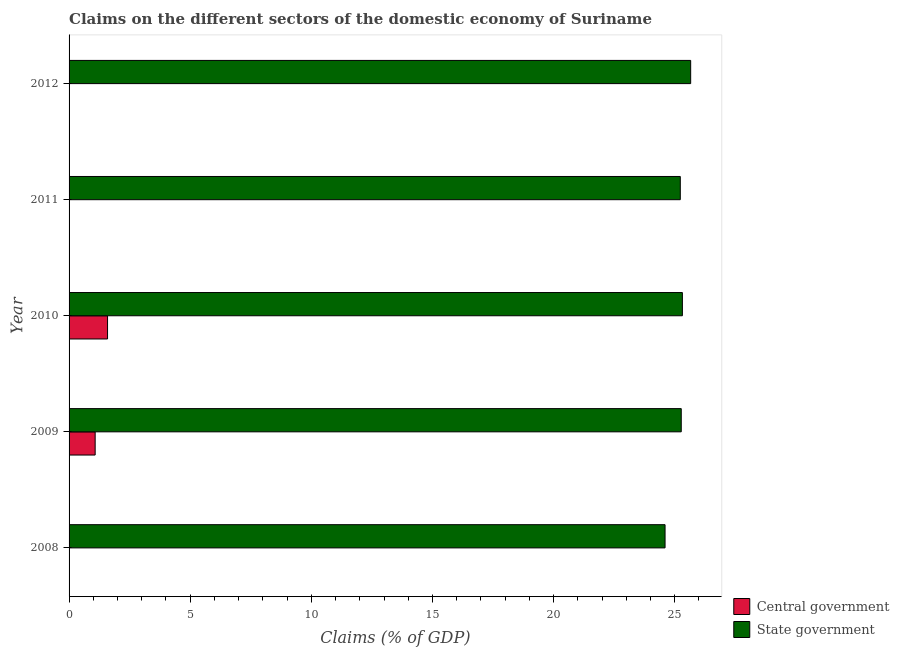What is the claims on state government in 2009?
Offer a very short reply. 25.27. Across all years, what is the maximum claims on state government?
Provide a short and direct response. 25.66. Across all years, what is the minimum claims on central government?
Make the answer very short. 0. What is the total claims on central government in the graph?
Provide a succinct answer. 2.67. What is the difference between the claims on state government in 2009 and that in 2010?
Offer a terse response. -0.05. What is the difference between the claims on central government in 2012 and the claims on state government in 2008?
Provide a short and direct response. -24.6. What is the average claims on central government per year?
Give a very brief answer. 0.53. In the year 2010, what is the difference between the claims on state government and claims on central government?
Your answer should be very brief. 23.73. In how many years, is the claims on central government greater than 1 %?
Provide a succinct answer. 2. Is the difference between the claims on state government in 2009 and 2010 greater than the difference between the claims on central government in 2009 and 2010?
Offer a terse response. Yes. What is the difference between the highest and the lowest claims on central government?
Provide a succinct answer. 1.59. In how many years, is the claims on central government greater than the average claims on central government taken over all years?
Offer a very short reply. 2. Is the sum of the claims on state government in 2008 and 2011 greater than the maximum claims on central government across all years?
Your response must be concise. Yes. How many bars are there?
Provide a succinct answer. 7. What is the difference between two consecutive major ticks on the X-axis?
Your response must be concise. 5. Where does the legend appear in the graph?
Keep it short and to the point. Bottom right. What is the title of the graph?
Provide a succinct answer. Claims on the different sectors of the domestic economy of Suriname. What is the label or title of the X-axis?
Your answer should be compact. Claims (% of GDP). What is the Claims (% of GDP) in State government in 2008?
Provide a short and direct response. 24.6. What is the Claims (% of GDP) of Central government in 2009?
Your response must be concise. 1.08. What is the Claims (% of GDP) in State government in 2009?
Your answer should be compact. 25.27. What is the Claims (% of GDP) of Central government in 2010?
Your answer should be very brief. 1.59. What is the Claims (% of GDP) of State government in 2010?
Offer a terse response. 25.32. What is the Claims (% of GDP) of Central government in 2011?
Make the answer very short. 0. What is the Claims (% of GDP) in State government in 2011?
Provide a short and direct response. 25.23. What is the Claims (% of GDP) of Central government in 2012?
Give a very brief answer. 0. What is the Claims (% of GDP) of State government in 2012?
Offer a very short reply. 25.66. Across all years, what is the maximum Claims (% of GDP) of Central government?
Provide a short and direct response. 1.59. Across all years, what is the maximum Claims (% of GDP) in State government?
Give a very brief answer. 25.66. Across all years, what is the minimum Claims (% of GDP) of State government?
Offer a very short reply. 24.6. What is the total Claims (% of GDP) of Central government in the graph?
Provide a short and direct response. 2.67. What is the total Claims (% of GDP) in State government in the graph?
Your answer should be compact. 126.08. What is the difference between the Claims (% of GDP) of State government in 2008 and that in 2009?
Your response must be concise. -0.67. What is the difference between the Claims (% of GDP) of State government in 2008 and that in 2010?
Provide a succinct answer. -0.72. What is the difference between the Claims (% of GDP) in State government in 2008 and that in 2011?
Offer a terse response. -0.63. What is the difference between the Claims (% of GDP) of State government in 2008 and that in 2012?
Offer a terse response. -1.06. What is the difference between the Claims (% of GDP) in Central government in 2009 and that in 2010?
Make the answer very short. -0.51. What is the difference between the Claims (% of GDP) of State government in 2009 and that in 2010?
Provide a succinct answer. -0.05. What is the difference between the Claims (% of GDP) in State government in 2009 and that in 2011?
Provide a succinct answer. 0.04. What is the difference between the Claims (% of GDP) in State government in 2009 and that in 2012?
Your answer should be compact. -0.39. What is the difference between the Claims (% of GDP) of State government in 2010 and that in 2011?
Your answer should be compact. 0.09. What is the difference between the Claims (% of GDP) of State government in 2010 and that in 2012?
Provide a short and direct response. -0.34. What is the difference between the Claims (% of GDP) of State government in 2011 and that in 2012?
Your answer should be compact. -0.43. What is the difference between the Claims (% of GDP) in Central government in 2009 and the Claims (% of GDP) in State government in 2010?
Your response must be concise. -24.24. What is the difference between the Claims (% of GDP) in Central government in 2009 and the Claims (% of GDP) in State government in 2011?
Ensure brevity in your answer.  -24.15. What is the difference between the Claims (% of GDP) of Central government in 2009 and the Claims (% of GDP) of State government in 2012?
Provide a short and direct response. -24.58. What is the difference between the Claims (% of GDP) of Central government in 2010 and the Claims (% of GDP) of State government in 2011?
Make the answer very short. -23.64. What is the difference between the Claims (% of GDP) in Central government in 2010 and the Claims (% of GDP) in State government in 2012?
Keep it short and to the point. -24.07. What is the average Claims (% of GDP) in Central government per year?
Your response must be concise. 0.53. What is the average Claims (% of GDP) in State government per year?
Keep it short and to the point. 25.22. In the year 2009, what is the difference between the Claims (% of GDP) of Central government and Claims (% of GDP) of State government?
Provide a succinct answer. -24.19. In the year 2010, what is the difference between the Claims (% of GDP) in Central government and Claims (% of GDP) in State government?
Offer a very short reply. -23.73. What is the ratio of the Claims (% of GDP) of State government in 2008 to that in 2009?
Offer a very short reply. 0.97. What is the ratio of the Claims (% of GDP) of State government in 2008 to that in 2010?
Keep it short and to the point. 0.97. What is the ratio of the Claims (% of GDP) of State government in 2008 to that in 2011?
Your response must be concise. 0.98. What is the ratio of the Claims (% of GDP) of State government in 2008 to that in 2012?
Offer a terse response. 0.96. What is the ratio of the Claims (% of GDP) in Central government in 2009 to that in 2010?
Make the answer very short. 0.68. What is the ratio of the Claims (% of GDP) of State government in 2010 to that in 2011?
Make the answer very short. 1. What is the ratio of the Claims (% of GDP) in State government in 2010 to that in 2012?
Offer a terse response. 0.99. What is the ratio of the Claims (% of GDP) of State government in 2011 to that in 2012?
Your answer should be very brief. 0.98. What is the difference between the highest and the second highest Claims (% of GDP) of State government?
Your response must be concise. 0.34. What is the difference between the highest and the lowest Claims (% of GDP) of Central government?
Your response must be concise. 1.59. What is the difference between the highest and the lowest Claims (% of GDP) in State government?
Provide a short and direct response. 1.06. 